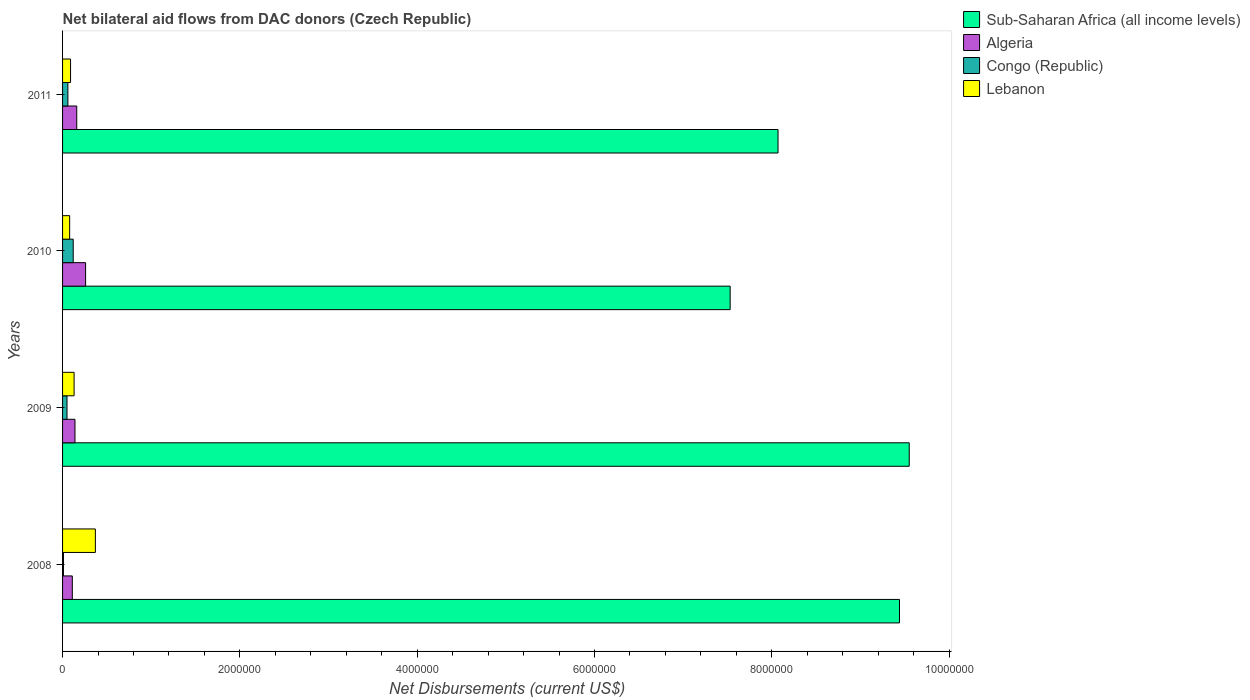How many groups of bars are there?
Your answer should be very brief. 4. Are the number of bars per tick equal to the number of legend labels?
Offer a very short reply. Yes. Are the number of bars on each tick of the Y-axis equal?
Your response must be concise. Yes. How many bars are there on the 2nd tick from the top?
Your answer should be compact. 4. How many bars are there on the 3rd tick from the bottom?
Give a very brief answer. 4. In how many cases, is the number of bars for a given year not equal to the number of legend labels?
Give a very brief answer. 0. What is the net bilateral aid flows in Algeria in 2010?
Make the answer very short. 2.60e+05. Across all years, what is the maximum net bilateral aid flows in Lebanon?
Your answer should be very brief. 3.70e+05. Across all years, what is the minimum net bilateral aid flows in Sub-Saharan Africa (all income levels)?
Ensure brevity in your answer.  7.53e+06. In which year was the net bilateral aid flows in Congo (Republic) minimum?
Your response must be concise. 2008. What is the total net bilateral aid flows in Sub-Saharan Africa (all income levels) in the graph?
Ensure brevity in your answer.  3.46e+07. What is the difference between the net bilateral aid flows in Sub-Saharan Africa (all income levels) in 2010 and that in 2011?
Give a very brief answer. -5.40e+05. What is the difference between the net bilateral aid flows in Algeria in 2010 and the net bilateral aid flows in Sub-Saharan Africa (all income levels) in 2009?
Offer a very short reply. -9.29e+06. What is the average net bilateral aid flows in Sub-Saharan Africa (all income levels) per year?
Offer a terse response. 8.65e+06. In the year 2011, what is the difference between the net bilateral aid flows in Sub-Saharan Africa (all income levels) and net bilateral aid flows in Congo (Republic)?
Your answer should be compact. 8.01e+06. What is the ratio of the net bilateral aid flows in Congo (Republic) in 2008 to that in 2010?
Your response must be concise. 0.08. Is the net bilateral aid flows in Algeria in 2009 less than that in 2011?
Your answer should be compact. Yes. Is the difference between the net bilateral aid flows in Sub-Saharan Africa (all income levels) in 2008 and 2010 greater than the difference between the net bilateral aid flows in Congo (Republic) in 2008 and 2010?
Provide a short and direct response. Yes. What is the difference between the highest and the second highest net bilateral aid flows in Algeria?
Offer a terse response. 1.00e+05. In how many years, is the net bilateral aid flows in Algeria greater than the average net bilateral aid flows in Algeria taken over all years?
Ensure brevity in your answer.  1. Is the sum of the net bilateral aid flows in Sub-Saharan Africa (all income levels) in 2009 and 2011 greater than the maximum net bilateral aid flows in Lebanon across all years?
Provide a short and direct response. Yes. What does the 1st bar from the top in 2009 represents?
Offer a very short reply. Lebanon. What does the 4th bar from the bottom in 2008 represents?
Make the answer very short. Lebanon. Are all the bars in the graph horizontal?
Ensure brevity in your answer.  Yes. How many years are there in the graph?
Provide a succinct answer. 4. Are the values on the major ticks of X-axis written in scientific E-notation?
Your response must be concise. No. How many legend labels are there?
Provide a short and direct response. 4. How are the legend labels stacked?
Offer a terse response. Vertical. What is the title of the graph?
Offer a terse response. Net bilateral aid flows from DAC donors (Czech Republic). What is the label or title of the X-axis?
Offer a very short reply. Net Disbursements (current US$). What is the label or title of the Y-axis?
Your answer should be very brief. Years. What is the Net Disbursements (current US$) of Sub-Saharan Africa (all income levels) in 2008?
Your response must be concise. 9.44e+06. What is the Net Disbursements (current US$) in Congo (Republic) in 2008?
Your answer should be very brief. 10000. What is the Net Disbursements (current US$) in Sub-Saharan Africa (all income levels) in 2009?
Your answer should be compact. 9.55e+06. What is the Net Disbursements (current US$) of Algeria in 2009?
Ensure brevity in your answer.  1.40e+05. What is the Net Disbursements (current US$) in Lebanon in 2009?
Make the answer very short. 1.30e+05. What is the Net Disbursements (current US$) of Sub-Saharan Africa (all income levels) in 2010?
Ensure brevity in your answer.  7.53e+06. What is the Net Disbursements (current US$) in Algeria in 2010?
Make the answer very short. 2.60e+05. What is the Net Disbursements (current US$) of Lebanon in 2010?
Ensure brevity in your answer.  8.00e+04. What is the Net Disbursements (current US$) in Sub-Saharan Africa (all income levels) in 2011?
Provide a succinct answer. 8.07e+06. What is the Net Disbursements (current US$) in Algeria in 2011?
Ensure brevity in your answer.  1.60e+05. What is the Net Disbursements (current US$) of Congo (Republic) in 2011?
Your answer should be compact. 6.00e+04. Across all years, what is the maximum Net Disbursements (current US$) of Sub-Saharan Africa (all income levels)?
Offer a terse response. 9.55e+06. Across all years, what is the maximum Net Disbursements (current US$) in Algeria?
Your answer should be compact. 2.60e+05. Across all years, what is the minimum Net Disbursements (current US$) of Sub-Saharan Africa (all income levels)?
Your answer should be compact. 7.53e+06. Across all years, what is the minimum Net Disbursements (current US$) of Congo (Republic)?
Make the answer very short. 10000. What is the total Net Disbursements (current US$) in Sub-Saharan Africa (all income levels) in the graph?
Ensure brevity in your answer.  3.46e+07. What is the total Net Disbursements (current US$) in Algeria in the graph?
Provide a succinct answer. 6.70e+05. What is the total Net Disbursements (current US$) of Lebanon in the graph?
Provide a succinct answer. 6.70e+05. What is the difference between the Net Disbursements (current US$) of Algeria in 2008 and that in 2009?
Provide a short and direct response. -3.00e+04. What is the difference between the Net Disbursements (current US$) of Congo (Republic) in 2008 and that in 2009?
Keep it short and to the point. -4.00e+04. What is the difference between the Net Disbursements (current US$) in Lebanon in 2008 and that in 2009?
Offer a very short reply. 2.40e+05. What is the difference between the Net Disbursements (current US$) of Sub-Saharan Africa (all income levels) in 2008 and that in 2010?
Ensure brevity in your answer.  1.91e+06. What is the difference between the Net Disbursements (current US$) in Algeria in 2008 and that in 2010?
Offer a terse response. -1.50e+05. What is the difference between the Net Disbursements (current US$) in Sub-Saharan Africa (all income levels) in 2008 and that in 2011?
Give a very brief answer. 1.37e+06. What is the difference between the Net Disbursements (current US$) in Lebanon in 2008 and that in 2011?
Provide a succinct answer. 2.80e+05. What is the difference between the Net Disbursements (current US$) in Sub-Saharan Africa (all income levels) in 2009 and that in 2010?
Provide a succinct answer. 2.02e+06. What is the difference between the Net Disbursements (current US$) of Lebanon in 2009 and that in 2010?
Ensure brevity in your answer.  5.00e+04. What is the difference between the Net Disbursements (current US$) in Sub-Saharan Africa (all income levels) in 2009 and that in 2011?
Ensure brevity in your answer.  1.48e+06. What is the difference between the Net Disbursements (current US$) of Congo (Republic) in 2009 and that in 2011?
Offer a terse response. -10000. What is the difference between the Net Disbursements (current US$) in Lebanon in 2009 and that in 2011?
Ensure brevity in your answer.  4.00e+04. What is the difference between the Net Disbursements (current US$) in Sub-Saharan Africa (all income levels) in 2010 and that in 2011?
Your answer should be compact. -5.40e+05. What is the difference between the Net Disbursements (current US$) of Lebanon in 2010 and that in 2011?
Offer a very short reply. -10000. What is the difference between the Net Disbursements (current US$) in Sub-Saharan Africa (all income levels) in 2008 and the Net Disbursements (current US$) in Algeria in 2009?
Provide a succinct answer. 9.30e+06. What is the difference between the Net Disbursements (current US$) of Sub-Saharan Africa (all income levels) in 2008 and the Net Disbursements (current US$) of Congo (Republic) in 2009?
Make the answer very short. 9.39e+06. What is the difference between the Net Disbursements (current US$) of Sub-Saharan Africa (all income levels) in 2008 and the Net Disbursements (current US$) of Lebanon in 2009?
Provide a short and direct response. 9.31e+06. What is the difference between the Net Disbursements (current US$) of Algeria in 2008 and the Net Disbursements (current US$) of Lebanon in 2009?
Give a very brief answer. -2.00e+04. What is the difference between the Net Disbursements (current US$) of Sub-Saharan Africa (all income levels) in 2008 and the Net Disbursements (current US$) of Algeria in 2010?
Make the answer very short. 9.18e+06. What is the difference between the Net Disbursements (current US$) in Sub-Saharan Africa (all income levels) in 2008 and the Net Disbursements (current US$) in Congo (Republic) in 2010?
Give a very brief answer. 9.32e+06. What is the difference between the Net Disbursements (current US$) in Sub-Saharan Africa (all income levels) in 2008 and the Net Disbursements (current US$) in Lebanon in 2010?
Ensure brevity in your answer.  9.36e+06. What is the difference between the Net Disbursements (current US$) of Congo (Republic) in 2008 and the Net Disbursements (current US$) of Lebanon in 2010?
Make the answer very short. -7.00e+04. What is the difference between the Net Disbursements (current US$) of Sub-Saharan Africa (all income levels) in 2008 and the Net Disbursements (current US$) of Algeria in 2011?
Ensure brevity in your answer.  9.28e+06. What is the difference between the Net Disbursements (current US$) of Sub-Saharan Africa (all income levels) in 2008 and the Net Disbursements (current US$) of Congo (Republic) in 2011?
Ensure brevity in your answer.  9.38e+06. What is the difference between the Net Disbursements (current US$) of Sub-Saharan Africa (all income levels) in 2008 and the Net Disbursements (current US$) of Lebanon in 2011?
Give a very brief answer. 9.35e+06. What is the difference between the Net Disbursements (current US$) of Algeria in 2008 and the Net Disbursements (current US$) of Lebanon in 2011?
Your answer should be compact. 2.00e+04. What is the difference between the Net Disbursements (current US$) in Congo (Republic) in 2008 and the Net Disbursements (current US$) in Lebanon in 2011?
Give a very brief answer. -8.00e+04. What is the difference between the Net Disbursements (current US$) in Sub-Saharan Africa (all income levels) in 2009 and the Net Disbursements (current US$) in Algeria in 2010?
Your answer should be very brief. 9.29e+06. What is the difference between the Net Disbursements (current US$) of Sub-Saharan Africa (all income levels) in 2009 and the Net Disbursements (current US$) of Congo (Republic) in 2010?
Make the answer very short. 9.43e+06. What is the difference between the Net Disbursements (current US$) of Sub-Saharan Africa (all income levels) in 2009 and the Net Disbursements (current US$) of Lebanon in 2010?
Provide a short and direct response. 9.47e+06. What is the difference between the Net Disbursements (current US$) in Algeria in 2009 and the Net Disbursements (current US$) in Congo (Republic) in 2010?
Give a very brief answer. 2.00e+04. What is the difference between the Net Disbursements (current US$) in Congo (Republic) in 2009 and the Net Disbursements (current US$) in Lebanon in 2010?
Provide a short and direct response. -3.00e+04. What is the difference between the Net Disbursements (current US$) in Sub-Saharan Africa (all income levels) in 2009 and the Net Disbursements (current US$) in Algeria in 2011?
Offer a very short reply. 9.39e+06. What is the difference between the Net Disbursements (current US$) in Sub-Saharan Africa (all income levels) in 2009 and the Net Disbursements (current US$) in Congo (Republic) in 2011?
Offer a terse response. 9.49e+06. What is the difference between the Net Disbursements (current US$) in Sub-Saharan Africa (all income levels) in 2009 and the Net Disbursements (current US$) in Lebanon in 2011?
Keep it short and to the point. 9.46e+06. What is the difference between the Net Disbursements (current US$) in Algeria in 2009 and the Net Disbursements (current US$) in Congo (Republic) in 2011?
Ensure brevity in your answer.  8.00e+04. What is the difference between the Net Disbursements (current US$) in Algeria in 2009 and the Net Disbursements (current US$) in Lebanon in 2011?
Keep it short and to the point. 5.00e+04. What is the difference between the Net Disbursements (current US$) of Sub-Saharan Africa (all income levels) in 2010 and the Net Disbursements (current US$) of Algeria in 2011?
Ensure brevity in your answer.  7.37e+06. What is the difference between the Net Disbursements (current US$) in Sub-Saharan Africa (all income levels) in 2010 and the Net Disbursements (current US$) in Congo (Republic) in 2011?
Your answer should be compact. 7.47e+06. What is the difference between the Net Disbursements (current US$) of Sub-Saharan Africa (all income levels) in 2010 and the Net Disbursements (current US$) of Lebanon in 2011?
Make the answer very short. 7.44e+06. What is the difference between the Net Disbursements (current US$) of Congo (Republic) in 2010 and the Net Disbursements (current US$) of Lebanon in 2011?
Your response must be concise. 3.00e+04. What is the average Net Disbursements (current US$) in Sub-Saharan Africa (all income levels) per year?
Keep it short and to the point. 8.65e+06. What is the average Net Disbursements (current US$) of Algeria per year?
Ensure brevity in your answer.  1.68e+05. What is the average Net Disbursements (current US$) in Lebanon per year?
Keep it short and to the point. 1.68e+05. In the year 2008, what is the difference between the Net Disbursements (current US$) in Sub-Saharan Africa (all income levels) and Net Disbursements (current US$) in Algeria?
Offer a very short reply. 9.33e+06. In the year 2008, what is the difference between the Net Disbursements (current US$) of Sub-Saharan Africa (all income levels) and Net Disbursements (current US$) of Congo (Republic)?
Your answer should be very brief. 9.43e+06. In the year 2008, what is the difference between the Net Disbursements (current US$) in Sub-Saharan Africa (all income levels) and Net Disbursements (current US$) in Lebanon?
Your answer should be compact. 9.07e+06. In the year 2008, what is the difference between the Net Disbursements (current US$) of Algeria and Net Disbursements (current US$) of Lebanon?
Keep it short and to the point. -2.60e+05. In the year 2008, what is the difference between the Net Disbursements (current US$) of Congo (Republic) and Net Disbursements (current US$) of Lebanon?
Make the answer very short. -3.60e+05. In the year 2009, what is the difference between the Net Disbursements (current US$) of Sub-Saharan Africa (all income levels) and Net Disbursements (current US$) of Algeria?
Offer a terse response. 9.41e+06. In the year 2009, what is the difference between the Net Disbursements (current US$) in Sub-Saharan Africa (all income levels) and Net Disbursements (current US$) in Congo (Republic)?
Offer a very short reply. 9.50e+06. In the year 2009, what is the difference between the Net Disbursements (current US$) of Sub-Saharan Africa (all income levels) and Net Disbursements (current US$) of Lebanon?
Make the answer very short. 9.42e+06. In the year 2009, what is the difference between the Net Disbursements (current US$) of Algeria and Net Disbursements (current US$) of Congo (Republic)?
Your answer should be compact. 9.00e+04. In the year 2010, what is the difference between the Net Disbursements (current US$) of Sub-Saharan Africa (all income levels) and Net Disbursements (current US$) of Algeria?
Your answer should be very brief. 7.27e+06. In the year 2010, what is the difference between the Net Disbursements (current US$) of Sub-Saharan Africa (all income levels) and Net Disbursements (current US$) of Congo (Republic)?
Ensure brevity in your answer.  7.41e+06. In the year 2010, what is the difference between the Net Disbursements (current US$) in Sub-Saharan Africa (all income levels) and Net Disbursements (current US$) in Lebanon?
Offer a terse response. 7.45e+06. In the year 2010, what is the difference between the Net Disbursements (current US$) of Congo (Republic) and Net Disbursements (current US$) of Lebanon?
Your answer should be compact. 4.00e+04. In the year 2011, what is the difference between the Net Disbursements (current US$) in Sub-Saharan Africa (all income levels) and Net Disbursements (current US$) in Algeria?
Your answer should be compact. 7.91e+06. In the year 2011, what is the difference between the Net Disbursements (current US$) in Sub-Saharan Africa (all income levels) and Net Disbursements (current US$) in Congo (Republic)?
Provide a short and direct response. 8.01e+06. In the year 2011, what is the difference between the Net Disbursements (current US$) of Sub-Saharan Africa (all income levels) and Net Disbursements (current US$) of Lebanon?
Offer a terse response. 7.98e+06. In the year 2011, what is the difference between the Net Disbursements (current US$) in Algeria and Net Disbursements (current US$) in Congo (Republic)?
Offer a very short reply. 1.00e+05. In the year 2011, what is the difference between the Net Disbursements (current US$) in Congo (Republic) and Net Disbursements (current US$) in Lebanon?
Provide a short and direct response. -3.00e+04. What is the ratio of the Net Disbursements (current US$) of Sub-Saharan Africa (all income levels) in 2008 to that in 2009?
Give a very brief answer. 0.99. What is the ratio of the Net Disbursements (current US$) of Algeria in 2008 to that in 2009?
Keep it short and to the point. 0.79. What is the ratio of the Net Disbursements (current US$) of Congo (Republic) in 2008 to that in 2009?
Make the answer very short. 0.2. What is the ratio of the Net Disbursements (current US$) in Lebanon in 2008 to that in 2009?
Ensure brevity in your answer.  2.85. What is the ratio of the Net Disbursements (current US$) of Sub-Saharan Africa (all income levels) in 2008 to that in 2010?
Provide a short and direct response. 1.25. What is the ratio of the Net Disbursements (current US$) of Algeria in 2008 to that in 2010?
Offer a terse response. 0.42. What is the ratio of the Net Disbursements (current US$) of Congo (Republic) in 2008 to that in 2010?
Provide a succinct answer. 0.08. What is the ratio of the Net Disbursements (current US$) of Lebanon in 2008 to that in 2010?
Provide a succinct answer. 4.62. What is the ratio of the Net Disbursements (current US$) in Sub-Saharan Africa (all income levels) in 2008 to that in 2011?
Keep it short and to the point. 1.17. What is the ratio of the Net Disbursements (current US$) of Algeria in 2008 to that in 2011?
Offer a very short reply. 0.69. What is the ratio of the Net Disbursements (current US$) in Congo (Republic) in 2008 to that in 2011?
Make the answer very short. 0.17. What is the ratio of the Net Disbursements (current US$) of Lebanon in 2008 to that in 2011?
Your answer should be very brief. 4.11. What is the ratio of the Net Disbursements (current US$) in Sub-Saharan Africa (all income levels) in 2009 to that in 2010?
Your answer should be very brief. 1.27. What is the ratio of the Net Disbursements (current US$) in Algeria in 2009 to that in 2010?
Provide a succinct answer. 0.54. What is the ratio of the Net Disbursements (current US$) in Congo (Republic) in 2009 to that in 2010?
Offer a terse response. 0.42. What is the ratio of the Net Disbursements (current US$) of Lebanon in 2009 to that in 2010?
Make the answer very short. 1.62. What is the ratio of the Net Disbursements (current US$) in Sub-Saharan Africa (all income levels) in 2009 to that in 2011?
Keep it short and to the point. 1.18. What is the ratio of the Net Disbursements (current US$) in Lebanon in 2009 to that in 2011?
Provide a short and direct response. 1.44. What is the ratio of the Net Disbursements (current US$) in Sub-Saharan Africa (all income levels) in 2010 to that in 2011?
Your answer should be compact. 0.93. What is the ratio of the Net Disbursements (current US$) in Algeria in 2010 to that in 2011?
Keep it short and to the point. 1.62. What is the ratio of the Net Disbursements (current US$) of Lebanon in 2010 to that in 2011?
Offer a terse response. 0.89. What is the difference between the highest and the lowest Net Disbursements (current US$) of Sub-Saharan Africa (all income levels)?
Your answer should be compact. 2.02e+06. What is the difference between the highest and the lowest Net Disbursements (current US$) of Congo (Republic)?
Your response must be concise. 1.10e+05. What is the difference between the highest and the lowest Net Disbursements (current US$) in Lebanon?
Give a very brief answer. 2.90e+05. 